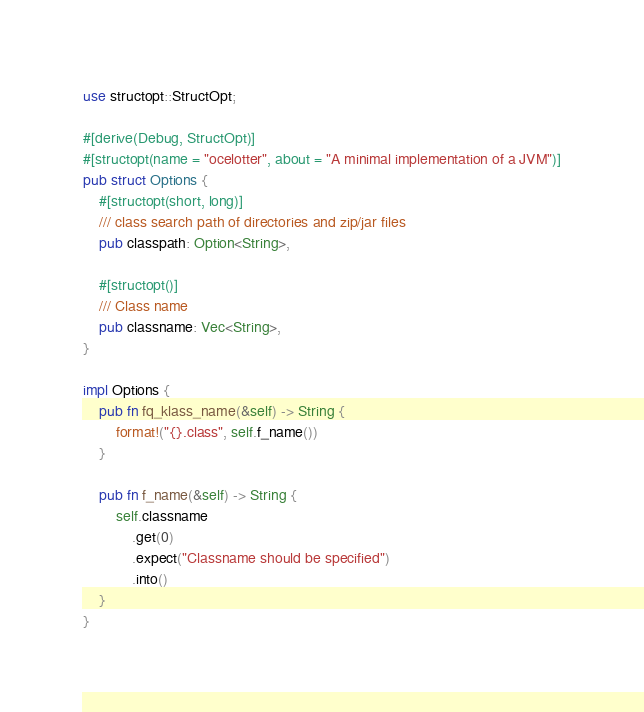Convert code to text. <code><loc_0><loc_0><loc_500><loc_500><_Rust_>use structopt::StructOpt;

#[derive(Debug, StructOpt)]
#[structopt(name = "ocelotter", about = "A minimal implementation of a JVM")]
pub struct Options {
    #[structopt(short, long)]
    /// class search path of directories and zip/jar files
    pub classpath: Option<String>,

    #[structopt()]
    /// Class name
    pub classname: Vec<String>,
}

impl Options {
    pub fn fq_klass_name(&self) -> String {
        format!("{}.class", self.f_name())
    }

    pub fn f_name(&self) -> String {
        self.classname
            .get(0)
            .expect("Classname should be specified")
            .into()
    }
}
</code> 